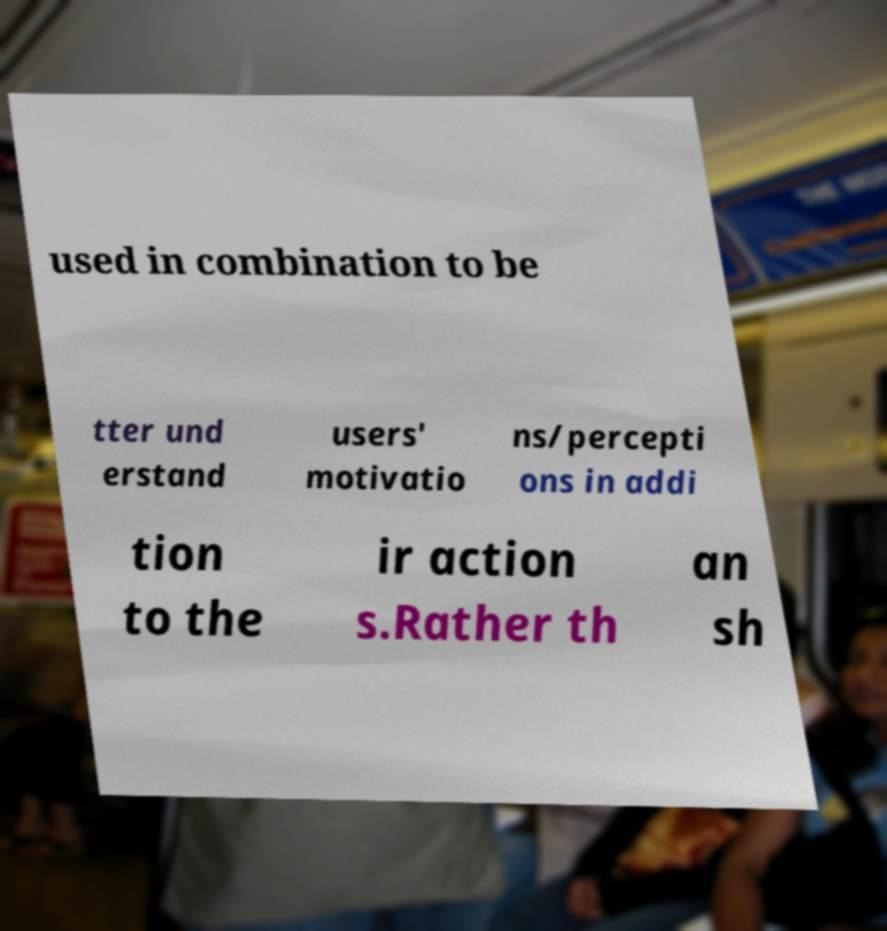I need the written content from this picture converted into text. Can you do that? used in combination to be tter und erstand users' motivatio ns/percepti ons in addi tion to the ir action s.Rather th an sh 